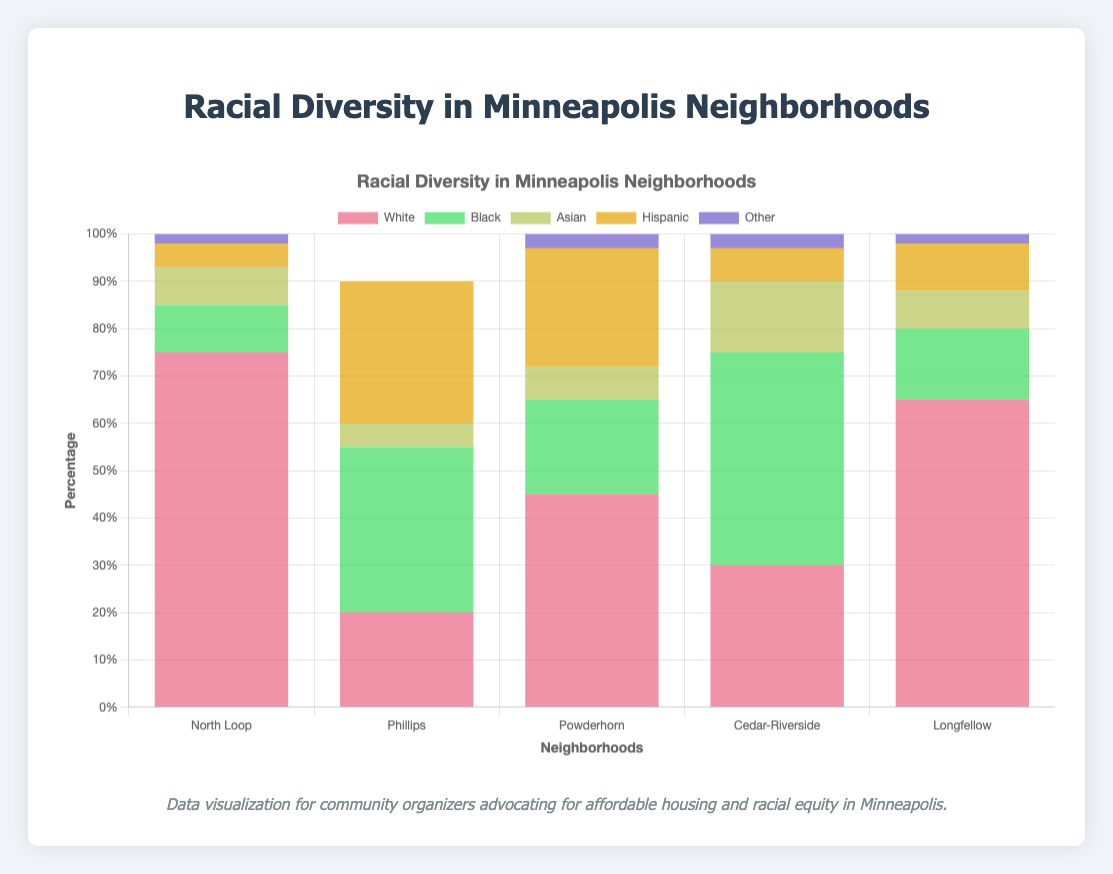Which neighborhood has the highest percentage of Black residents? Phillips has the highest percentage of Black residents at 35%, as indicated by the data and the segment for "👨🏿 Black" in the bar chart.
Answer: Phillips What is the sum of the percentage of Asian residents in North Loop and Cedar-Riverside? In North Loop, the percentage for Asian residents is 8%, and in Cedar-Riverside, it is 15%. Adding these together results in 8% + 15% = 23%.
Answer: 23% Which two neighborhoods have the same percentage of Hispanic residents? Both North Loop and Cedar-Riverside have 7% of Hispanic residents, represented by the "👨🏽 Hispanic" emoji and bar percentage.
Answer: North Loop and Cedar-Riverside Which neighborhood is the most racially diverse, with no single ethnic group holding a majority? Phillips is the most racially diverse, as the highest percentage for any single group is 35% (Black), with significant percentages for Hispanic (30%), White (20%), and Native American (10%). No single group is a majority.
Answer: Phillips Compare the percentage of White residents in Longfellow and North Loop. Which has more, and how much more? Longfellow has 65% White residents, while North Loop has 75%. North Loop has 10% more White residents than Longfellow.
Answer: North Loop, 10% more What is the average percentage of Hispanic residents across all neighborhoods? Summing the percentages of Hispanic residents in all neighborhoods: 5% (North Loop) + 30% (Phillips) + 25% (Powderhorn) + 7% (Cedar-Riverside) + 10% (Longfellow) = 77%. Dividing by 5 (number of neighborhoods) results in an average of 77% / 5 = 15.4%.
Answer: 15.4% What is the difference in the percentage of Black residents between Cedar-Riverside and Longfellow? Cedar-Riverside has 45% of Black residents, while Longfellow has 15%. The difference is 45% - 15% = 30%.
Answer: 30% Which neighborhood has the smallest percentage of "Other" ethnicities? Both North Loop and Longfellow have the smallest percentage of "Other" ethnicities at 2%, as seen in their respective bar sections for "👥 Other".
Answer: North Loop and Longfellow What are the top three neighborhoods with the highest percentage of Asian residents? The top three neighborhoods with the highest percentage of Asian residents are Cedar-Riverside (15%), North Loop (8%), and Longfellow (8%).
Answer: Cedar-Riverside, North Loop, Longfellow What is the total percentage of Native American residents in all neighborhoods (assuming unlisted neighborhoods have 0%)? Only Phillips has Native American residents listed at 10%. Summing these gives a total percentage of 10%.
Answer: 10% 